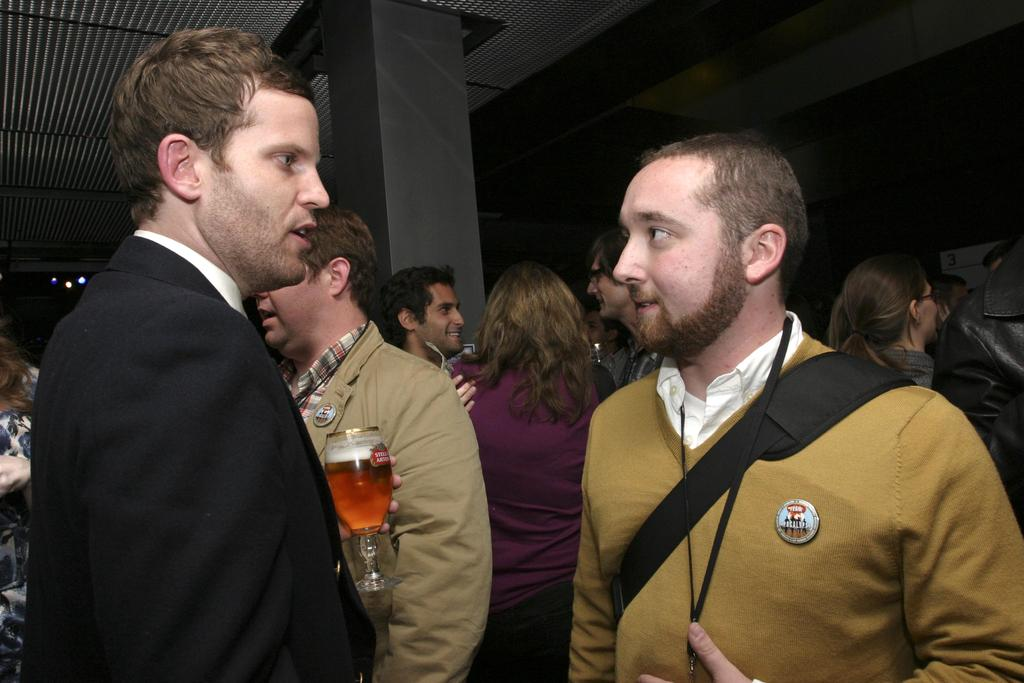How many people are in the image? There are persons in the image, but the exact number is not specified. Can you describe the man on the left side of the image? The man on the left side of the image is holding a glass with liquid in his hand. What can be seen in the background of the image? There is a pillar, objects, and a roof visible in the background of the image. What type of grape is the man eating in the image? There is no grape present in the image; the man is holding a glass with liquid in his hand. How many steps are visible in the image? There is no mention of steps in the image; it only features a man holding a glass, a pillar, objects, and a roof in the background. 